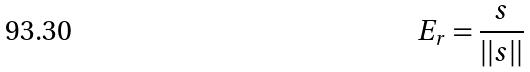<formula> <loc_0><loc_0><loc_500><loc_500>E _ { r } = \frac { s } { | | s | | }</formula> 